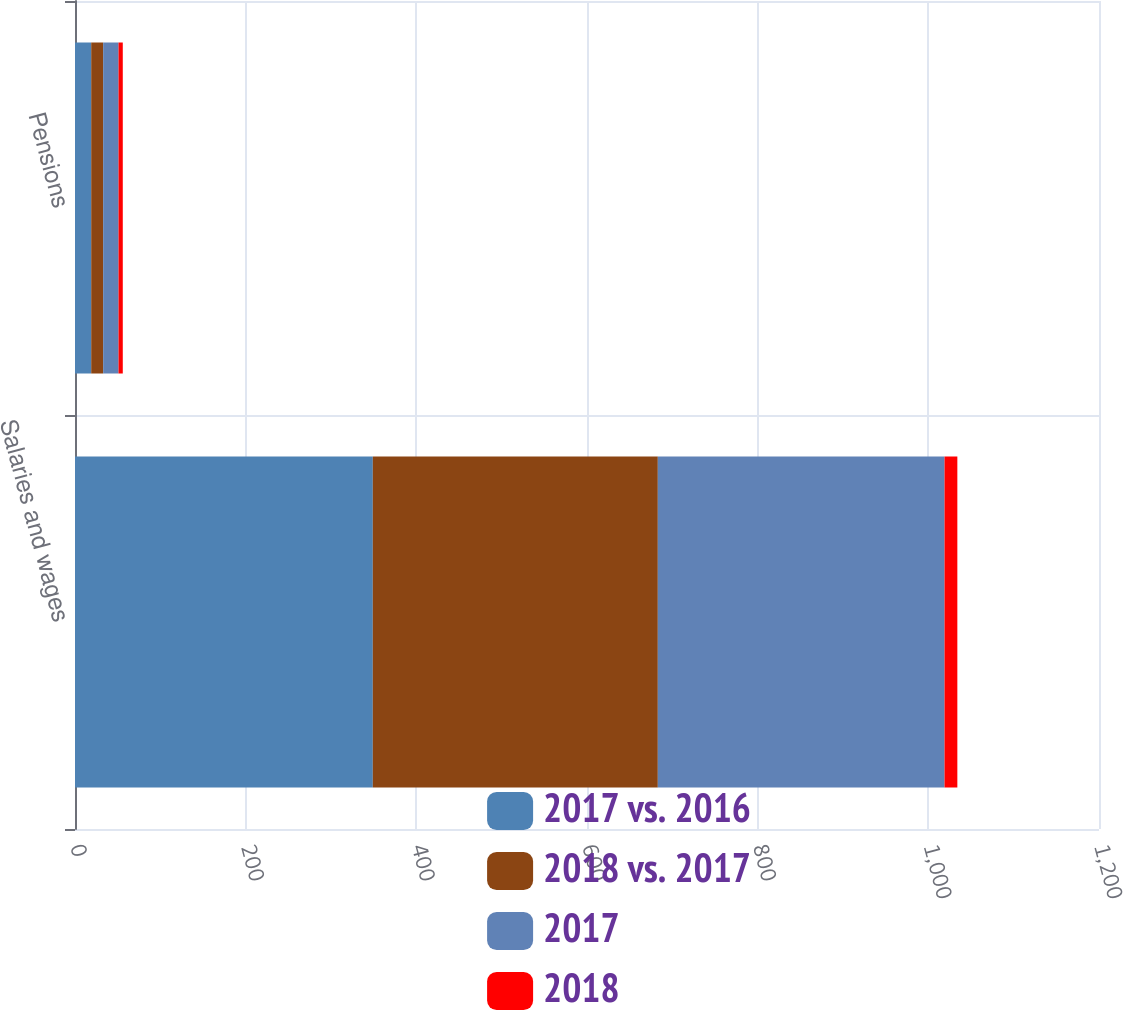Convert chart to OTSL. <chart><loc_0><loc_0><loc_500><loc_500><stacked_bar_chart><ecel><fcel>Salaries and wages<fcel>Pensions<nl><fcel>2017 vs. 2016<fcel>349<fcel>19<nl><fcel>2018 vs. 2017<fcel>334<fcel>14<nl><fcel>2017<fcel>336<fcel>18<nl><fcel>2018<fcel>15<fcel>5<nl></chart> 